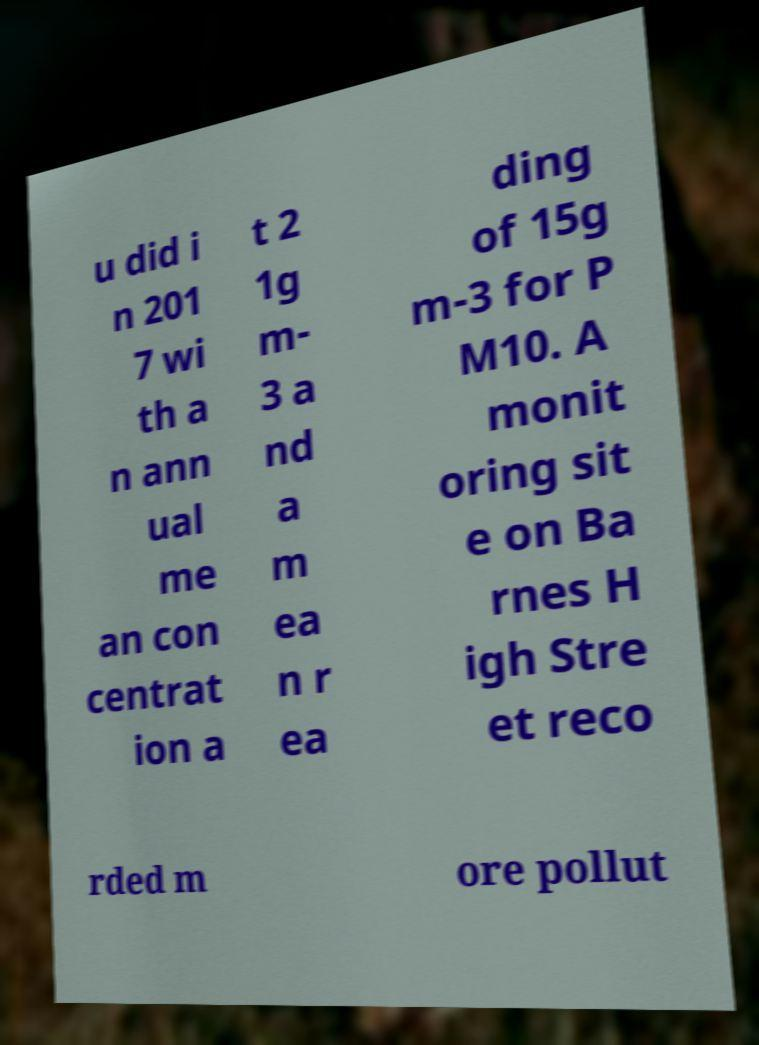There's text embedded in this image that I need extracted. Can you transcribe it verbatim? u did i n 201 7 wi th a n ann ual me an con centrat ion a t 2 1g m- 3 a nd a m ea n r ea ding of 15g m-3 for P M10. A monit oring sit e on Ba rnes H igh Stre et reco rded m ore pollut 